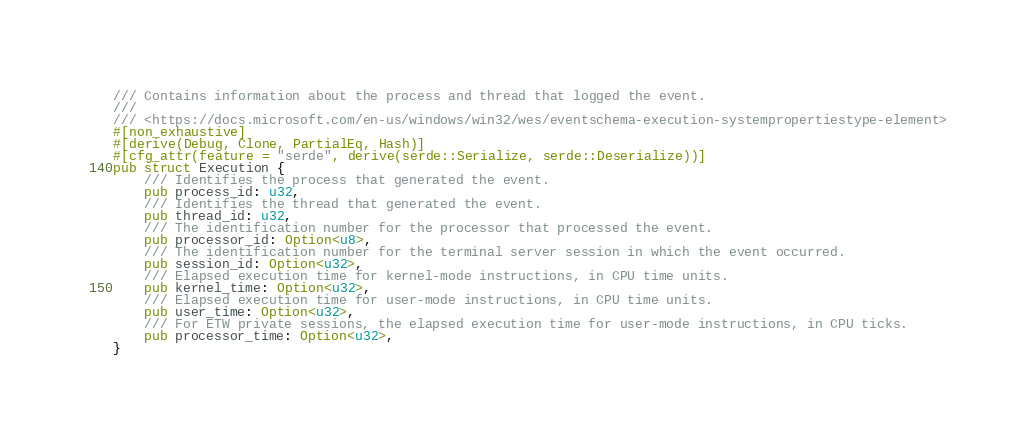<code> <loc_0><loc_0><loc_500><loc_500><_Rust_>/// Contains information about the process and thread that logged the event.
///
/// <https://docs.microsoft.com/en-us/windows/win32/wes/eventschema-execution-systempropertiestype-element>
#[non_exhaustive]
#[derive(Debug, Clone, PartialEq, Hash)]
#[cfg_attr(feature = "serde", derive(serde::Serialize, serde::Deserialize))]
pub struct Execution {
    /// Identifies the process that generated the event.
    pub process_id: u32,
    /// Identifies the thread that generated the event.
    pub thread_id: u32,
    /// The identification number for the processor that processed the event.
    pub processor_id: Option<u8>,
    /// The identification number for the terminal server session in which the event occurred.
    pub session_id: Option<u32>,
    /// Elapsed execution time for kernel-mode instructions, in CPU time units.
    pub kernel_time: Option<u32>,
    /// Elapsed execution time for user-mode instructions, in CPU time units.
    pub user_time: Option<u32>,
    /// For ETW private sessions, the elapsed execution time for user-mode instructions, in CPU ticks.
    pub processor_time: Option<u32>,
}
</code> 